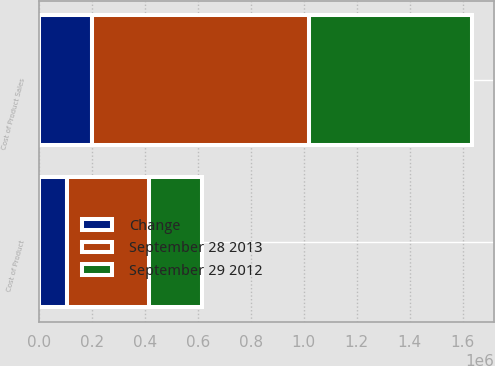<chart> <loc_0><loc_0><loc_500><loc_500><stacked_bar_chart><ecel><fcel>Cost of Product Sales<fcel>Cost of Product<nl><fcel>September 28 2013<fcel>818160<fcel>307895<nl><fcel>September 29 2012<fcel>616839<fcel>201864<nl><fcel>Change<fcel>201321<fcel>106031<nl></chart> 